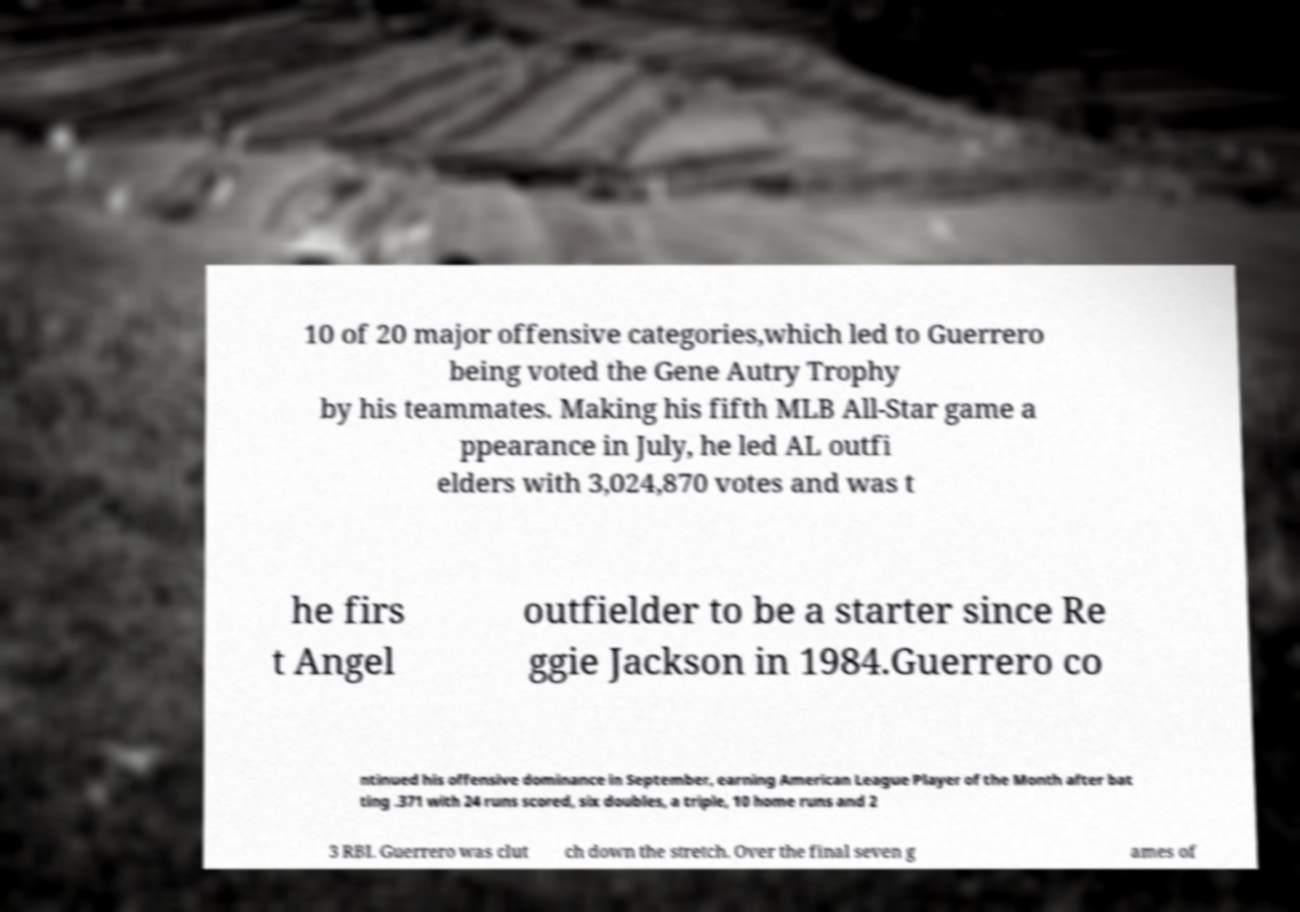Could you assist in decoding the text presented in this image and type it out clearly? 10 of 20 major offensive categories,which led to Guerrero being voted the Gene Autry Trophy by his teammates. Making his fifth MLB All-Star game a ppearance in July, he led AL outfi elders with 3,024,870 votes and was t he firs t Angel outfielder to be a starter since Re ggie Jackson in 1984.Guerrero co ntinued his offensive dominance in September, earning American League Player of the Month after bat ting .371 with 24 runs scored, six doubles, a triple, 10 home runs and 2 3 RBI. Guerrero was clut ch down the stretch. Over the final seven g ames of 